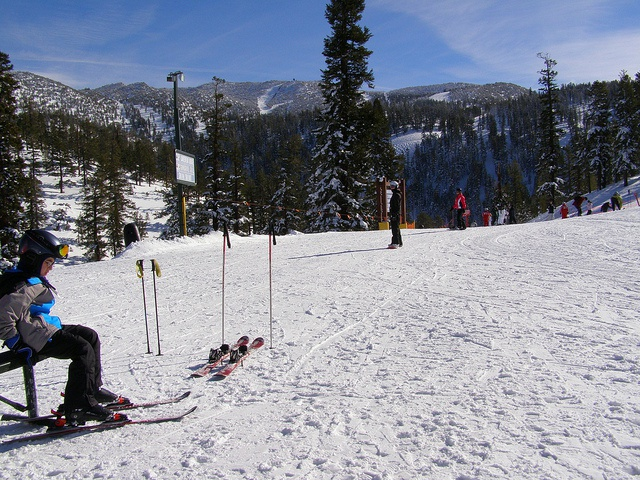Describe the objects in this image and their specific colors. I can see people in gray, black, navy, and darkgray tones, skis in gray, black, darkgray, and maroon tones, skis in gray, darkgray, brown, and lightgray tones, people in gray, black, lightgray, and darkgray tones, and people in gray, black, maroon, brown, and navy tones in this image. 